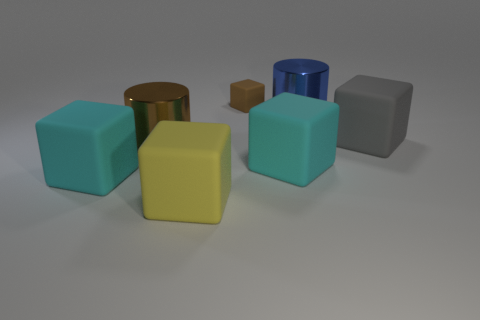Subtract all green spheres. How many cyan blocks are left? 2 Subtract all gray rubber cubes. How many cubes are left? 4 Subtract all cyan blocks. How many blocks are left? 3 Add 2 small blue things. How many objects exist? 9 Subtract all brown cubes. Subtract all green spheres. How many cubes are left? 4 Subtract all cylinders. How many objects are left? 5 Add 5 large brown cylinders. How many large brown cylinders are left? 6 Add 1 purple matte cylinders. How many purple matte cylinders exist? 1 Subtract 0 red blocks. How many objects are left? 7 Subtract all gray cubes. Subtract all big yellow blocks. How many objects are left? 5 